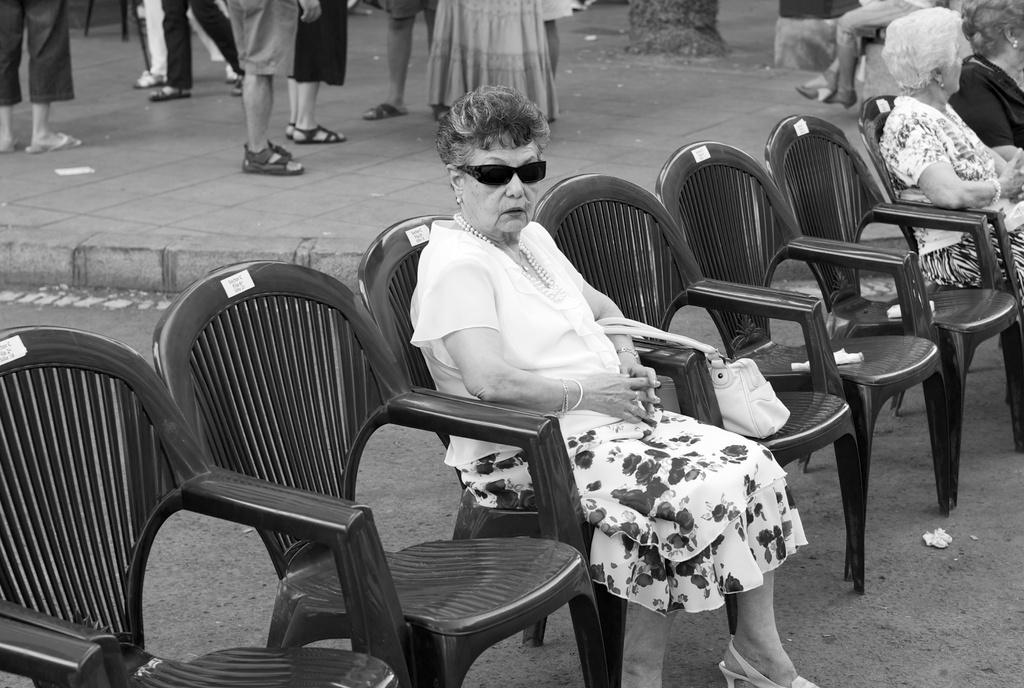How many women are sitting in chairs in the image? There are two women sitting in chairs in the image. What is the position of the other chairs in the image? There are empty chairs in the image. Are there any people standing in the image? Yes, there are people standing behind the chairs. What type of account does the woman sitting in the chair have with the people standing behind her? There is no indication of any account or interaction between the woman sitting in the chair and the people standing behind her in the image. 